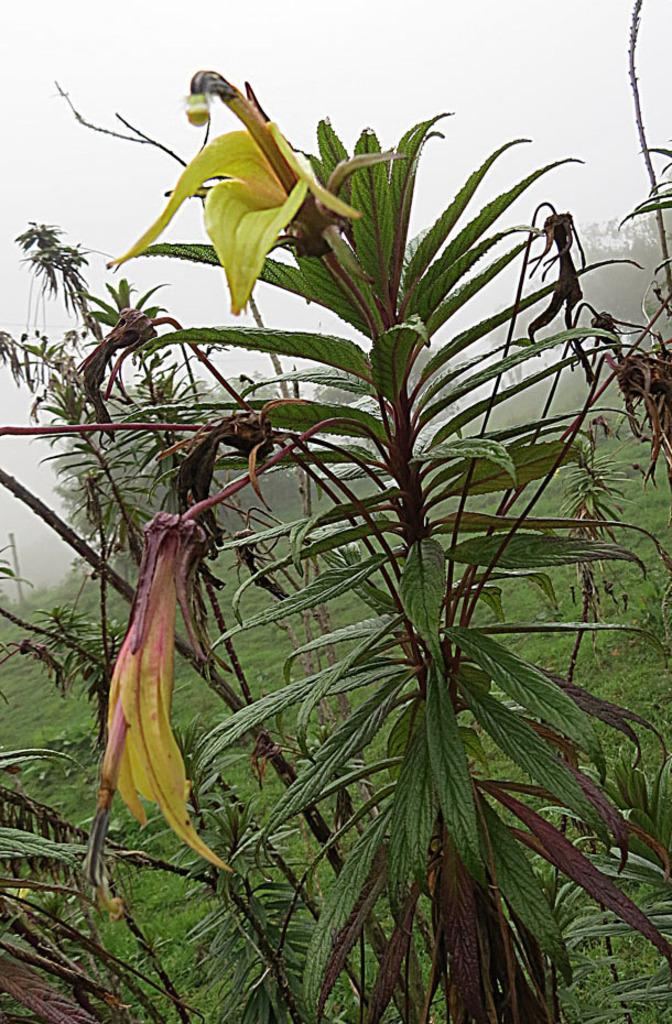What type of vegetation can be seen in the image? There are plants and flowers in the image. What can be seen in the background of the image? There is grass, trees, and the sky visible in the background of the image. What type of noise can be heard coming from the plants in the image? There is no noise coming from the plants in the image, as plants do not produce sound. 